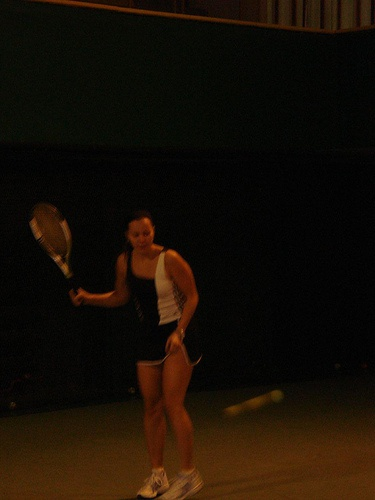Describe the objects in this image and their specific colors. I can see people in black, maroon, and brown tones, tennis racket in black, maroon, and brown tones, sports ball in maroon and black tones, and sports ball in maroon and black tones in this image. 